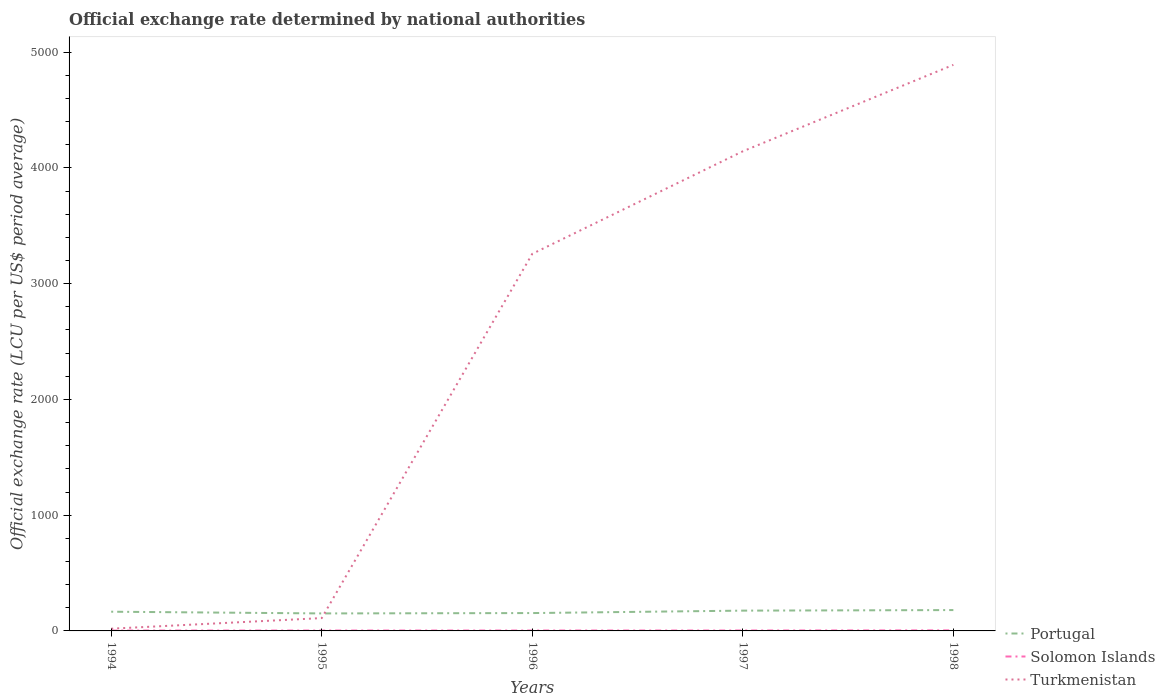Across all years, what is the maximum official exchange rate in Turkmenistan?
Your answer should be very brief. 19.2. In which year was the official exchange rate in Solomon Islands maximum?
Give a very brief answer. 1994. What is the total official exchange rate in Turkmenistan in the graph?
Your answer should be compact. -3238.47. What is the difference between the highest and the second highest official exchange rate in Portugal?
Offer a terse response. 29. What is the difference between the highest and the lowest official exchange rate in Solomon Islands?
Ensure brevity in your answer.  1. Are the values on the major ticks of Y-axis written in scientific E-notation?
Make the answer very short. No. Does the graph contain any zero values?
Your answer should be very brief. No. Does the graph contain grids?
Make the answer very short. No. Where does the legend appear in the graph?
Offer a very short reply. Bottom right. How are the legend labels stacked?
Ensure brevity in your answer.  Vertical. What is the title of the graph?
Your answer should be very brief. Official exchange rate determined by national authorities. Does "Greece" appear as one of the legend labels in the graph?
Provide a succinct answer. No. What is the label or title of the Y-axis?
Your response must be concise. Official exchange rate (LCU per US$ period average). What is the Official exchange rate (LCU per US$ period average) in Portugal in 1994?
Keep it short and to the point. 165.99. What is the Official exchange rate (LCU per US$ period average) of Solomon Islands in 1994?
Offer a terse response. 3.29. What is the Official exchange rate (LCU per US$ period average) of Turkmenistan in 1994?
Offer a terse response. 19.2. What is the Official exchange rate (LCU per US$ period average) of Portugal in 1995?
Ensure brevity in your answer.  151.11. What is the Official exchange rate (LCU per US$ period average) of Solomon Islands in 1995?
Provide a succinct answer. 3.41. What is the Official exchange rate (LCU per US$ period average) in Turkmenistan in 1995?
Your response must be concise. 110.92. What is the Official exchange rate (LCU per US$ period average) of Portugal in 1996?
Make the answer very short. 154.24. What is the Official exchange rate (LCU per US$ period average) of Solomon Islands in 1996?
Give a very brief answer. 3.57. What is the Official exchange rate (LCU per US$ period average) of Turkmenistan in 1996?
Provide a short and direct response. 3257.67. What is the Official exchange rate (LCU per US$ period average) in Portugal in 1997?
Your answer should be compact. 175.31. What is the Official exchange rate (LCU per US$ period average) of Solomon Islands in 1997?
Ensure brevity in your answer.  3.72. What is the Official exchange rate (LCU per US$ period average) in Turkmenistan in 1997?
Provide a short and direct response. 4143.42. What is the Official exchange rate (LCU per US$ period average) in Portugal in 1998?
Your answer should be very brief. 180.1. What is the Official exchange rate (LCU per US$ period average) in Solomon Islands in 1998?
Offer a terse response. 4.82. What is the Official exchange rate (LCU per US$ period average) in Turkmenistan in 1998?
Give a very brief answer. 4890.17. Across all years, what is the maximum Official exchange rate (LCU per US$ period average) of Portugal?
Your answer should be very brief. 180.1. Across all years, what is the maximum Official exchange rate (LCU per US$ period average) of Solomon Islands?
Keep it short and to the point. 4.82. Across all years, what is the maximum Official exchange rate (LCU per US$ period average) of Turkmenistan?
Your answer should be compact. 4890.17. Across all years, what is the minimum Official exchange rate (LCU per US$ period average) of Portugal?
Your response must be concise. 151.11. Across all years, what is the minimum Official exchange rate (LCU per US$ period average) in Solomon Islands?
Provide a short and direct response. 3.29. Across all years, what is the minimum Official exchange rate (LCU per US$ period average) of Turkmenistan?
Your response must be concise. 19.2. What is the total Official exchange rate (LCU per US$ period average) of Portugal in the graph?
Offer a terse response. 826.76. What is the total Official exchange rate (LCU per US$ period average) of Solomon Islands in the graph?
Keep it short and to the point. 18.8. What is the total Official exchange rate (LCU per US$ period average) in Turkmenistan in the graph?
Offer a terse response. 1.24e+04. What is the difference between the Official exchange rate (LCU per US$ period average) of Portugal in 1994 and that in 1995?
Offer a very short reply. 14.89. What is the difference between the Official exchange rate (LCU per US$ period average) of Solomon Islands in 1994 and that in 1995?
Give a very brief answer. -0.11. What is the difference between the Official exchange rate (LCU per US$ period average) of Turkmenistan in 1994 and that in 1995?
Offer a very short reply. -91.72. What is the difference between the Official exchange rate (LCU per US$ period average) of Portugal in 1994 and that in 1996?
Provide a succinct answer. 11.75. What is the difference between the Official exchange rate (LCU per US$ period average) in Solomon Islands in 1994 and that in 1996?
Your answer should be compact. -0.28. What is the difference between the Official exchange rate (LCU per US$ period average) of Turkmenistan in 1994 and that in 1996?
Make the answer very short. -3238.47. What is the difference between the Official exchange rate (LCU per US$ period average) in Portugal in 1994 and that in 1997?
Your answer should be very brief. -9.32. What is the difference between the Official exchange rate (LCU per US$ period average) in Solomon Islands in 1994 and that in 1997?
Provide a short and direct response. -0.43. What is the difference between the Official exchange rate (LCU per US$ period average) in Turkmenistan in 1994 and that in 1997?
Provide a short and direct response. -4124.22. What is the difference between the Official exchange rate (LCU per US$ period average) of Portugal in 1994 and that in 1998?
Your response must be concise. -14.11. What is the difference between the Official exchange rate (LCU per US$ period average) in Solomon Islands in 1994 and that in 1998?
Make the answer very short. -1.52. What is the difference between the Official exchange rate (LCU per US$ period average) in Turkmenistan in 1994 and that in 1998?
Ensure brevity in your answer.  -4870.97. What is the difference between the Official exchange rate (LCU per US$ period average) in Portugal in 1995 and that in 1996?
Keep it short and to the point. -3.14. What is the difference between the Official exchange rate (LCU per US$ period average) of Solomon Islands in 1995 and that in 1996?
Offer a terse response. -0.16. What is the difference between the Official exchange rate (LCU per US$ period average) in Turkmenistan in 1995 and that in 1996?
Provide a succinct answer. -3146.75. What is the difference between the Official exchange rate (LCU per US$ period average) in Portugal in 1995 and that in 1997?
Offer a very short reply. -24.21. What is the difference between the Official exchange rate (LCU per US$ period average) of Solomon Islands in 1995 and that in 1997?
Provide a short and direct response. -0.31. What is the difference between the Official exchange rate (LCU per US$ period average) of Turkmenistan in 1995 and that in 1997?
Ensure brevity in your answer.  -4032.5. What is the difference between the Official exchange rate (LCU per US$ period average) in Portugal in 1995 and that in 1998?
Ensure brevity in your answer.  -29. What is the difference between the Official exchange rate (LCU per US$ period average) of Solomon Islands in 1995 and that in 1998?
Ensure brevity in your answer.  -1.41. What is the difference between the Official exchange rate (LCU per US$ period average) of Turkmenistan in 1995 and that in 1998?
Your answer should be compact. -4779.25. What is the difference between the Official exchange rate (LCU per US$ period average) of Portugal in 1996 and that in 1997?
Provide a short and direct response. -21.07. What is the difference between the Official exchange rate (LCU per US$ period average) in Solomon Islands in 1996 and that in 1997?
Give a very brief answer. -0.15. What is the difference between the Official exchange rate (LCU per US$ period average) of Turkmenistan in 1996 and that in 1997?
Your answer should be very brief. -885.75. What is the difference between the Official exchange rate (LCU per US$ period average) in Portugal in 1996 and that in 1998?
Keep it short and to the point. -25.86. What is the difference between the Official exchange rate (LCU per US$ period average) in Solomon Islands in 1996 and that in 1998?
Provide a short and direct response. -1.25. What is the difference between the Official exchange rate (LCU per US$ period average) in Turkmenistan in 1996 and that in 1998?
Ensure brevity in your answer.  -1632.5. What is the difference between the Official exchange rate (LCU per US$ period average) in Portugal in 1997 and that in 1998?
Your answer should be compact. -4.79. What is the difference between the Official exchange rate (LCU per US$ period average) in Solomon Islands in 1997 and that in 1998?
Ensure brevity in your answer.  -1.1. What is the difference between the Official exchange rate (LCU per US$ period average) in Turkmenistan in 1997 and that in 1998?
Make the answer very short. -746.75. What is the difference between the Official exchange rate (LCU per US$ period average) in Portugal in 1994 and the Official exchange rate (LCU per US$ period average) in Solomon Islands in 1995?
Provide a succinct answer. 162.59. What is the difference between the Official exchange rate (LCU per US$ period average) in Portugal in 1994 and the Official exchange rate (LCU per US$ period average) in Turkmenistan in 1995?
Make the answer very short. 55.08. What is the difference between the Official exchange rate (LCU per US$ period average) in Solomon Islands in 1994 and the Official exchange rate (LCU per US$ period average) in Turkmenistan in 1995?
Ensure brevity in your answer.  -107.63. What is the difference between the Official exchange rate (LCU per US$ period average) of Portugal in 1994 and the Official exchange rate (LCU per US$ period average) of Solomon Islands in 1996?
Keep it short and to the point. 162.43. What is the difference between the Official exchange rate (LCU per US$ period average) in Portugal in 1994 and the Official exchange rate (LCU per US$ period average) in Turkmenistan in 1996?
Provide a succinct answer. -3091.67. What is the difference between the Official exchange rate (LCU per US$ period average) of Solomon Islands in 1994 and the Official exchange rate (LCU per US$ period average) of Turkmenistan in 1996?
Make the answer very short. -3254.38. What is the difference between the Official exchange rate (LCU per US$ period average) of Portugal in 1994 and the Official exchange rate (LCU per US$ period average) of Solomon Islands in 1997?
Make the answer very short. 162.28. What is the difference between the Official exchange rate (LCU per US$ period average) of Portugal in 1994 and the Official exchange rate (LCU per US$ period average) of Turkmenistan in 1997?
Keep it short and to the point. -3977.42. What is the difference between the Official exchange rate (LCU per US$ period average) in Solomon Islands in 1994 and the Official exchange rate (LCU per US$ period average) in Turkmenistan in 1997?
Keep it short and to the point. -4140.13. What is the difference between the Official exchange rate (LCU per US$ period average) of Portugal in 1994 and the Official exchange rate (LCU per US$ period average) of Solomon Islands in 1998?
Your answer should be very brief. 161.18. What is the difference between the Official exchange rate (LCU per US$ period average) of Portugal in 1994 and the Official exchange rate (LCU per US$ period average) of Turkmenistan in 1998?
Offer a terse response. -4724.17. What is the difference between the Official exchange rate (LCU per US$ period average) of Solomon Islands in 1994 and the Official exchange rate (LCU per US$ period average) of Turkmenistan in 1998?
Ensure brevity in your answer.  -4886.88. What is the difference between the Official exchange rate (LCU per US$ period average) of Portugal in 1995 and the Official exchange rate (LCU per US$ period average) of Solomon Islands in 1996?
Keep it short and to the point. 147.54. What is the difference between the Official exchange rate (LCU per US$ period average) in Portugal in 1995 and the Official exchange rate (LCU per US$ period average) in Turkmenistan in 1996?
Offer a very short reply. -3106.56. What is the difference between the Official exchange rate (LCU per US$ period average) in Solomon Islands in 1995 and the Official exchange rate (LCU per US$ period average) in Turkmenistan in 1996?
Your answer should be compact. -3254.26. What is the difference between the Official exchange rate (LCU per US$ period average) in Portugal in 1995 and the Official exchange rate (LCU per US$ period average) in Solomon Islands in 1997?
Make the answer very short. 147.39. What is the difference between the Official exchange rate (LCU per US$ period average) of Portugal in 1995 and the Official exchange rate (LCU per US$ period average) of Turkmenistan in 1997?
Provide a short and direct response. -3992.31. What is the difference between the Official exchange rate (LCU per US$ period average) in Solomon Islands in 1995 and the Official exchange rate (LCU per US$ period average) in Turkmenistan in 1997?
Offer a terse response. -4140.01. What is the difference between the Official exchange rate (LCU per US$ period average) of Portugal in 1995 and the Official exchange rate (LCU per US$ period average) of Solomon Islands in 1998?
Your answer should be very brief. 146.29. What is the difference between the Official exchange rate (LCU per US$ period average) in Portugal in 1995 and the Official exchange rate (LCU per US$ period average) in Turkmenistan in 1998?
Offer a terse response. -4739.06. What is the difference between the Official exchange rate (LCU per US$ period average) of Solomon Islands in 1995 and the Official exchange rate (LCU per US$ period average) of Turkmenistan in 1998?
Your answer should be very brief. -4886.76. What is the difference between the Official exchange rate (LCU per US$ period average) of Portugal in 1996 and the Official exchange rate (LCU per US$ period average) of Solomon Islands in 1997?
Provide a succinct answer. 150.53. What is the difference between the Official exchange rate (LCU per US$ period average) in Portugal in 1996 and the Official exchange rate (LCU per US$ period average) in Turkmenistan in 1997?
Ensure brevity in your answer.  -3989.17. What is the difference between the Official exchange rate (LCU per US$ period average) of Solomon Islands in 1996 and the Official exchange rate (LCU per US$ period average) of Turkmenistan in 1997?
Your answer should be very brief. -4139.85. What is the difference between the Official exchange rate (LCU per US$ period average) of Portugal in 1996 and the Official exchange rate (LCU per US$ period average) of Solomon Islands in 1998?
Ensure brevity in your answer.  149.43. What is the difference between the Official exchange rate (LCU per US$ period average) of Portugal in 1996 and the Official exchange rate (LCU per US$ period average) of Turkmenistan in 1998?
Ensure brevity in your answer.  -4735.92. What is the difference between the Official exchange rate (LCU per US$ period average) of Solomon Islands in 1996 and the Official exchange rate (LCU per US$ period average) of Turkmenistan in 1998?
Offer a very short reply. -4886.6. What is the difference between the Official exchange rate (LCU per US$ period average) of Portugal in 1997 and the Official exchange rate (LCU per US$ period average) of Solomon Islands in 1998?
Your answer should be compact. 170.5. What is the difference between the Official exchange rate (LCU per US$ period average) in Portugal in 1997 and the Official exchange rate (LCU per US$ period average) in Turkmenistan in 1998?
Your answer should be compact. -4714.85. What is the difference between the Official exchange rate (LCU per US$ period average) of Solomon Islands in 1997 and the Official exchange rate (LCU per US$ period average) of Turkmenistan in 1998?
Offer a very short reply. -4886.45. What is the average Official exchange rate (LCU per US$ period average) in Portugal per year?
Provide a short and direct response. 165.35. What is the average Official exchange rate (LCU per US$ period average) of Solomon Islands per year?
Your answer should be very brief. 3.76. What is the average Official exchange rate (LCU per US$ period average) in Turkmenistan per year?
Your response must be concise. 2484.27. In the year 1994, what is the difference between the Official exchange rate (LCU per US$ period average) of Portugal and Official exchange rate (LCU per US$ period average) of Solomon Islands?
Keep it short and to the point. 162.7. In the year 1994, what is the difference between the Official exchange rate (LCU per US$ period average) of Portugal and Official exchange rate (LCU per US$ period average) of Turkmenistan?
Your answer should be very brief. 146.79. In the year 1994, what is the difference between the Official exchange rate (LCU per US$ period average) in Solomon Islands and Official exchange rate (LCU per US$ period average) in Turkmenistan?
Your response must be concise. -15.91. In the year 1995, what is the difference between the Official exchange rate (LCU per US$ period average) in Portugal and Official exchange rate (LCU per US$ period average) in Solomon Islands?
Provide a succinct answer. 147.7. In the year 1995, what is the difference between the Official exchange rate (LCU per US$ period average) of Portugal and Official exchange rate (LCU per US$ period average) of Turkmenistan?
Make the answer very short. 40.19. In the year 1995, what is the difference between the Official exchange rate (LCU per US$ period average) in Solomon Islands and Official exchange rate (LCU per US$ period average) in Turkmenistan?
Provide a short and direct response. -107.51. In the year 1996, what is the difference between the Official exchange rate (LCU per US$ period average) in Portugal and Official exchange rate (LCU per US$ period average) in Solomon Islands?
Make the answer very short. 150.68. In the year 1996, what is the difference between the Official exchange rate (LCU per US$ period average) of Portugal and Official exchange rate (LCU per US$ period average) of Turkmenistan?
Offer a very short reply. -3103.42. In the year 1996, what is the difference between the Official exchange rate (LCU per US$ period average) of Solomon Islands and Official exchange rate (LCU per US$ period average) of Turkmenistan?
Ensure brevity in your answer.  -3254.1. In the year 1997, what is the difference between the Official exchange rate (LCU per US$ period average) of Portugal and Official exchange rate (LCU per US$ period average) of Solomon Islands?
Offer a very short reply. 171.6. In the year 1997, what is the difference between the Official exchange rate (LCU per US$ period average) of Portugal and Official exchange rate (LCU per US$ period average) of Turkmenistan?
Offer a terse response. -3968.1. In the year 1997, what is the difference between the Official exchange rate (LCU per US$ period average) in Solomon Islands and Official exchange rate (LCU per US$ period average) in Turkmenistan?
Your response must be concise. -4139.7. In the year 1998, what is the difference between the Official exchange rate (LCU per US$ period average) in Portugal and Official exchange rate (LCU per US$ period average) in Solomon Islands?
Offer a terse response. 175.29. In the year 1998, what is the difference between the Official exchange rate (LCU per US$ period average) of Portugal and Official exchange rate (LCU per US$ period average) of Turkmenistan?
Offer a terse response. -4710.06. In the year 1998, what is the difference between the Official exchange rate (LCU per US$ period average) of Solomon Islands and Official exchange rate (LCU per US$ period average) of Turkmenistan?
Provide a short and direct response. -4885.35. What is the ratio of the Official exchange rate (LCU per US$ period average) of Portugal in 1994 to that in 1995?
Provide a succinct answer. 1.1. What is the ratio of the Official exchange rate (LCU per US$ period average) in Solomon Islands in 1994 to that in 1995?
Your answer should be very brief. 0.97. What is the ratio of the Official exchange rate (LCU per US$ period average) of Turkmenistan in 1994 to that in 1995?
Ensure brevity in your answer.  0.17. What is the ratio of the Official exchange rate (LCU per US$ period average) of Portugal in 1994 to that in 1996?
Your response must be concise. 1.08. What is the ratio of the Official exchange rate (LCU per US$ period average) of Solomon Islands in 1994 to that in 1996?
Offer a very short reply. 0.92. What is the ratio of the Official exchange rate (LCU per US$ period average) in Turkmenistan in 1994 to that in 1996?
Offer a very short reply. 0.01. What is the ratio of the Official exchange rate (LCU per US$ period average) in Portugal in 1994 to that in 1997?
Your answer should be compact. 0.95. What is the ratio of the Official exchange rate (LCU per US$ period average) in Solomon Islands in 1994 to that in 1997?
Your answer should be compact. 0.89. What is the ratio of the Official exchange rate (LCU per US$ period average) of Turkmenistan in 1994 to that in 1997?
Provide a succinct answer. 0. What is the ratio of the Official exchange rate (LCU per US$ period average) in Portugal in 1994 to that in 1998?
Ensure brevity in your answer.  0.92. What is the ratio of the Official exchange rate (LCU per US$ period average) in Solomon Islands in 1994 to that in 1998?
Provide a succinct answer. 0.68. What is the ratio of the Official exchange rate (LCU per US$ period average) in Turkmenistan in 1994 to that in 1998?
Give a very brief answer. 0. What is the ratio of the Official exchange rate (LCU per US$ period average) in Portugal in 1995 to that in 1996?
Make the answer very short. 0.98. What is the ratio of the Official exchange rate (LCU per US$ period average) of Solomon Islands in 1995 to that in 1996?
Offer a very short reply. 0.95. What is the ratio of the Official exchange rate (LCU per US$ period average) of Turkmenistan in 1995 to that in 1996?
Make the answer very short. 0.03. What is the ratio of the Official exchange rate (LCU per US$ period average) in Portugal in 1995 to that in 1997?
Your answer should be compact. 0.86. What is the ratio of the Official exchange rate (LCU per US$ period average) in Solomon Islands in 1995 to that in 1997?
Provide a short and direct response. 0.92. What is the ratio of the Official exchange rate (LCU per US$ period average) in Turkmenistan in 1995 to that in 1997?
Keep it short and to the point. 0.03. What is the ratio of the Official exchange rate (LCU per US$ period average) in Portugal in 1995 to that in 1998?
Offer a very short reply. 0.84. What is the ratio of the Official exchange rate (LCU per US$ period average) in Solomon Islands in 1995 to that in 1998?
Offer a very short reply. 0.71. What is the ratio of the Official exchange rate (LCU per US$ period average) of Turkmenistan in 1995 to that in 1998?
Your answer should be very brief. 0.02. What is the ratio of the Official exchange rate (LCU per US$ period average) in Portugal in 1996 to that in 1997?
Provide a succinct answer. 0.88. What is the ratio of the Official exchange rate (LCU per US$ period average) of Solomon Islands in 1996 to that in 1997?
Your answer should be very brief. 0.96. What is the ratio of the Official exchange rate (LCU per US$ period average) in Turkmenistan in 1996 to that in 1997?
Provide a succinct answer. 0.79. What is the ratio of the Official exchange rate (LCU per US$ period average) in Portugal in 1996 to that in 1998?
Provide a short and direct response. 0.86. What is the ratio of the Official exchange rate (LCU per US$ period average) in Solomon Islands in 1996 to that in 1998?
Provide a succinct answer. 0.74. What is the ratio of the Official exchange rate (LCU per US$ period average) of Turkmenistan in 1996 to that in 1998?
Provide a succinct answer. 0.67. What is the ratio of the Official exchange rate (LCU per US$ period average) of Portugal in 1997 to that in 1998?
Provide a short and direct response. 0.97. What is the ratio of the Official exchange rate (LCU per US$ period average) in Solomon Islands in 1997 to that in 1998?
Your answer should be compact. 0.77. What is the ratio of the Official exchange rate (LCU per US$ period average) of Turkmenistan in 1997 to that in 1998?
Make the answer very short. 0.85. What is the difference between the highest and the second highest Official exchange rate (LCU per US$ period average) of Portugal?
Provide a succinct answer. 4.79. What is the difference between the highest and the second highest Official exchange rate (LCU per US$ period average) in Solomon Islands?
Provide a succinct answer. 1.1. What is the difference between the highest and the second highest Official exchange rate (LCU per US$ period average) in Turkmenistan?
Offer a very short reply. 746.75. What is the difference between the highest and the lowest Official exchange rate (LCU per US$ period average) in Portugal?
Provide a succinct answer. 29. What is the difference between the highest and the lowest Official exchange rate (LCU per US$ period average) of Solomon Islands?
Ensure brevity in your answer.  1.52. What is the difference between the highest and the lowest Official exchange rate (LCU per US$ period average) in Turkmenistan?
Provide a short and direct response. 4870.97. 